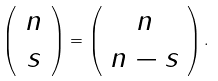<formula> <loc_0><loc_0><loc_500><loc_500>\left ( \begin{array} { c } n \\ s \end{array} \right ) = \left ( \begin{array} { c } n \\ n - s \end{array} \right ) .</formula> 